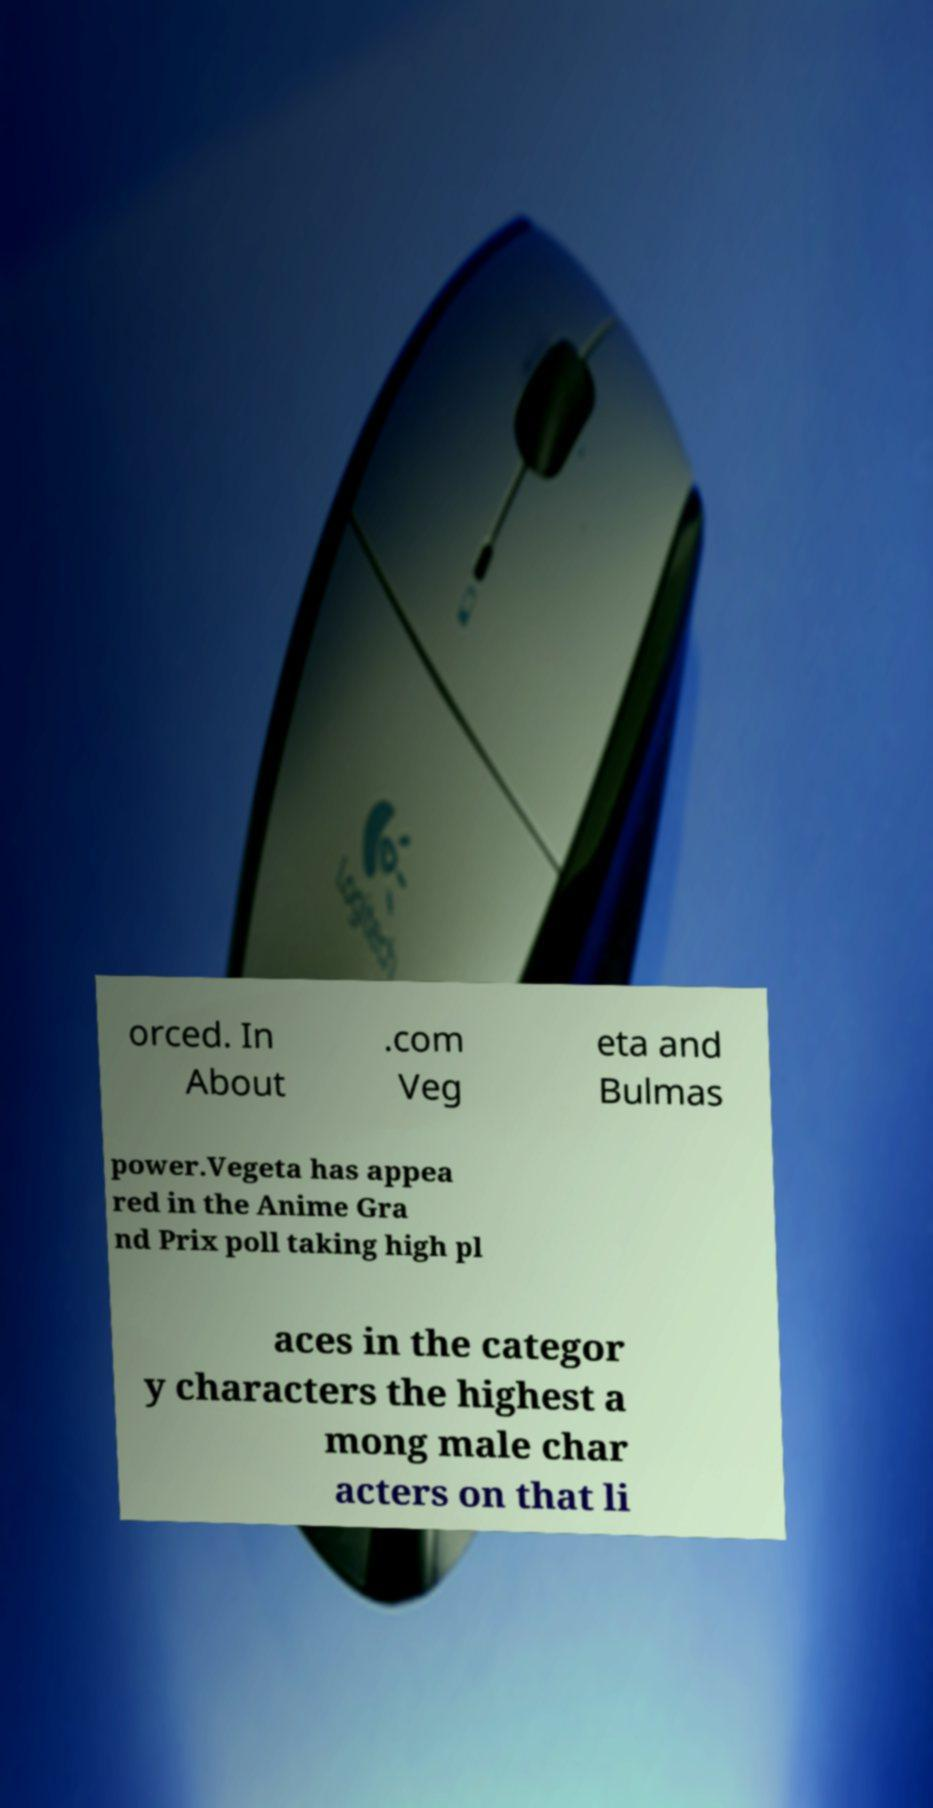Could you assist in decoding the text presented in this image and type it out clearly? orced. In About .com Veg eta and Bulmas power.Vegeta has appea red in the Anime Gra nd Prix poll taking high pl aces in the categor y characters the highest a mong male char acters on that li 